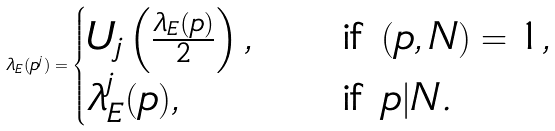Convert formula to latex. <formula><loc_0><loc_0><loc_500><loc_500>\lambda _ { E } ( p ^ { j } ) = \begin{cases} U _ { j } \left ( \frac { \lambda _ { E } ( p ) } { 2 } \right ) , \quad & \text {if $(p,N) = 1$} , \\ \lambda _ { E } ^ { j } ( p ) , \quad & \text {if $p | N$} . \end{cases}</formula> 